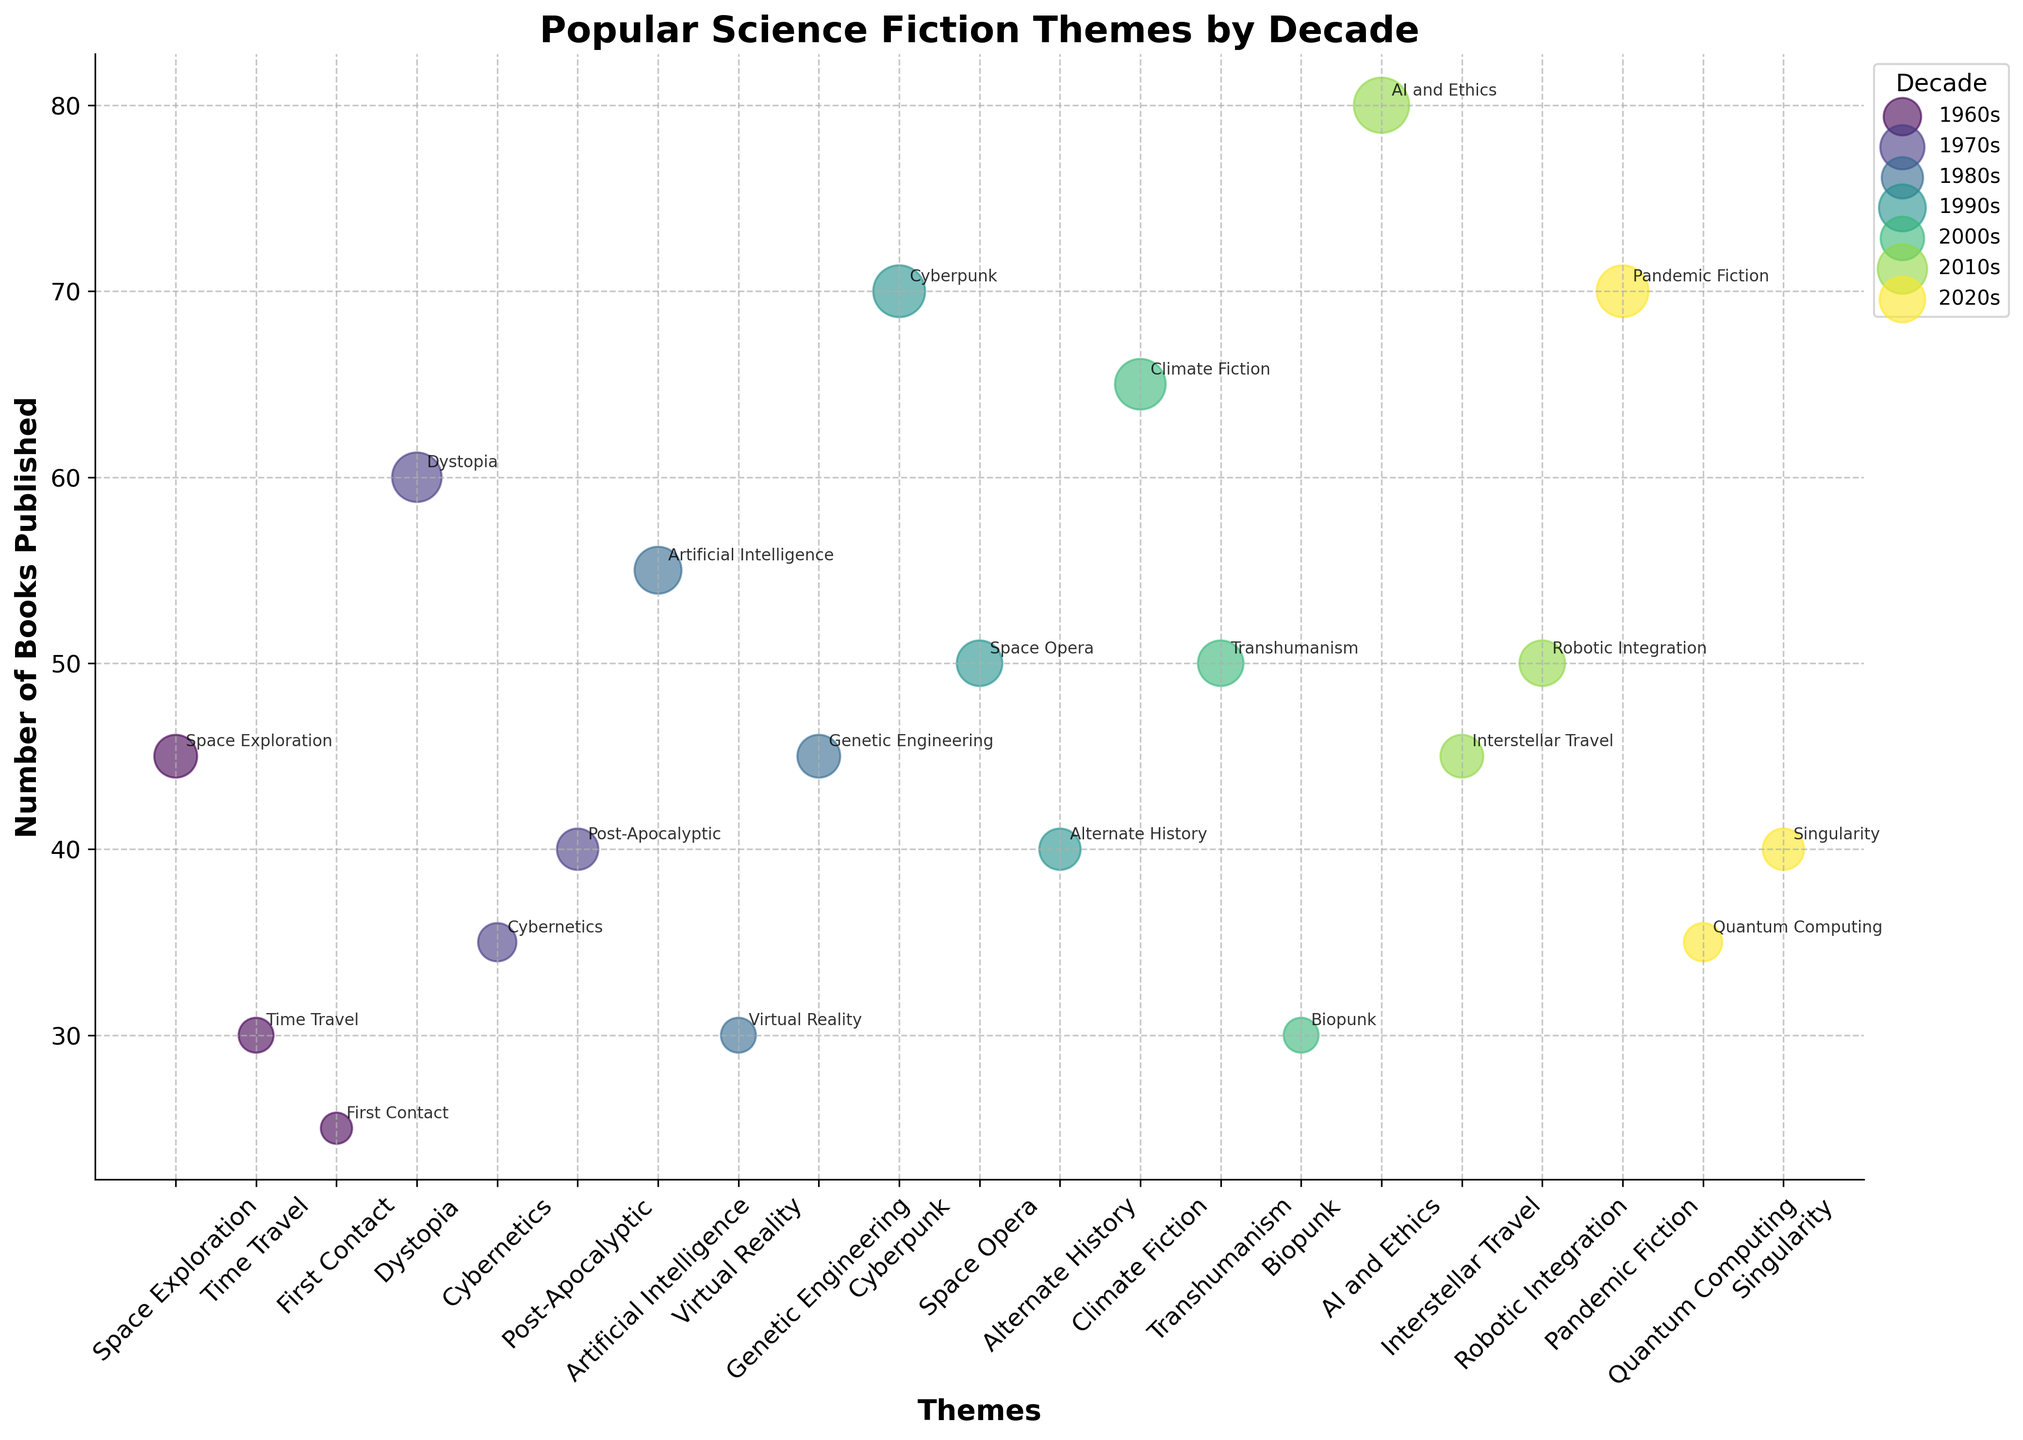What's the title of the plot? The plot title is typically found at the top of the figure and describes the overall content. In this case, it indicates the comparison of Science Fiction Themes by Decade based on the number of books published.
Answer: Popular Science Fiction Themes by Decade What theme in the 1960s had the highest number of books published? To find this, look for the largest bubble under the 1960s in the x-axis. The highest number in the 1960s corresponds to "Space Exploration", which has 45 books published.
Answer: Space Exploration Which decade had the theme "Dystopia" emerging? Identify in which decade "Dystopia" appears as a label in the x-axis and observe its corresponding bubble. It appears under the 1970s.
Answer: 1970s How many themes in total are there in the 2010s? Count the number of distinct bubbles plotted for the 2010s. Themes in the 2010s include "AI and Ethics", "Interstellar Travel", and "Robotic Integration".
Answer: 3 Which theme has the largest bubble in the 2010s decade? To determine this, compare the sizes of the bubbles in the 2010s. The biggest bubble corresponds to "AI and Ethics".
Answer: AI and Ethics What is the difference in the number of books published between the "Cyberpunk" and "Singularity" themes? Locate "Cyberpunk" and "Singularity" bubbles, note their respective numbers of books published (70 and 40), and subtract the smaller from the larger.
Answer: 30 In which decade did the number of books published for the theme "Post-Apocalyptic" first exceed 30? Evaluate the decades where "Post-Apocalyptic" appears and check if the number of books exceeds 30. It first exceeds 30 in the 1970s.
Answer: 1970s Compare the number of books published on "Artificial Intelligence" in the 1980s to "Robotic Integration" in the 2010s. Which had more? Look at the numbers associated with both themes. "Artificial Intelligence" in the 1980s has 55 books published, while "Robotic Integration" in the 2010s has 50.
Answer: Artificial Intelligence Which theme had a relatively stable number of books published across multiple decades? Identify a theme with similar bubble sizes and numbers across different decades. "Space Exploration" appears in multiple decades with relatively uniform sizes in the 1960s and 1990s.
Answer: Space Exploration What trend can you observe about themes related to artificial intelligence over the decades? Observe the bubbles related to AI, such as "Artificial Intelligence" in the 1980s and "AI and Ethics" in the 2010s. There's a noticeable increase in the number of books published, showing growing interest.
Answer: Increasing trend 